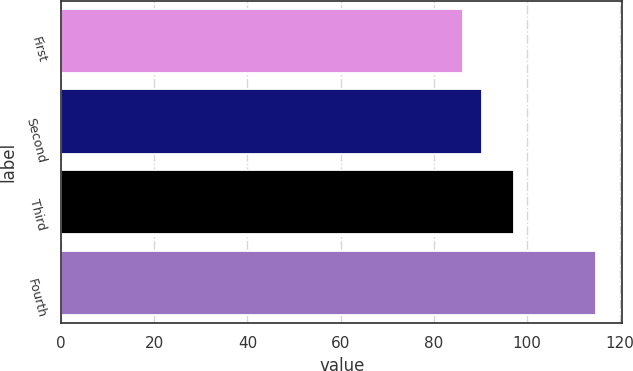<chart> <loc_0><loc_0><loc_500><loc_500><bar_chart><fcel>First<fcel>Second<fcel>Third<fcel>Fourth<nl><fcel>86.31<fcel>90.34<fcel>97.12<fcel>114.75<nl></chart> 